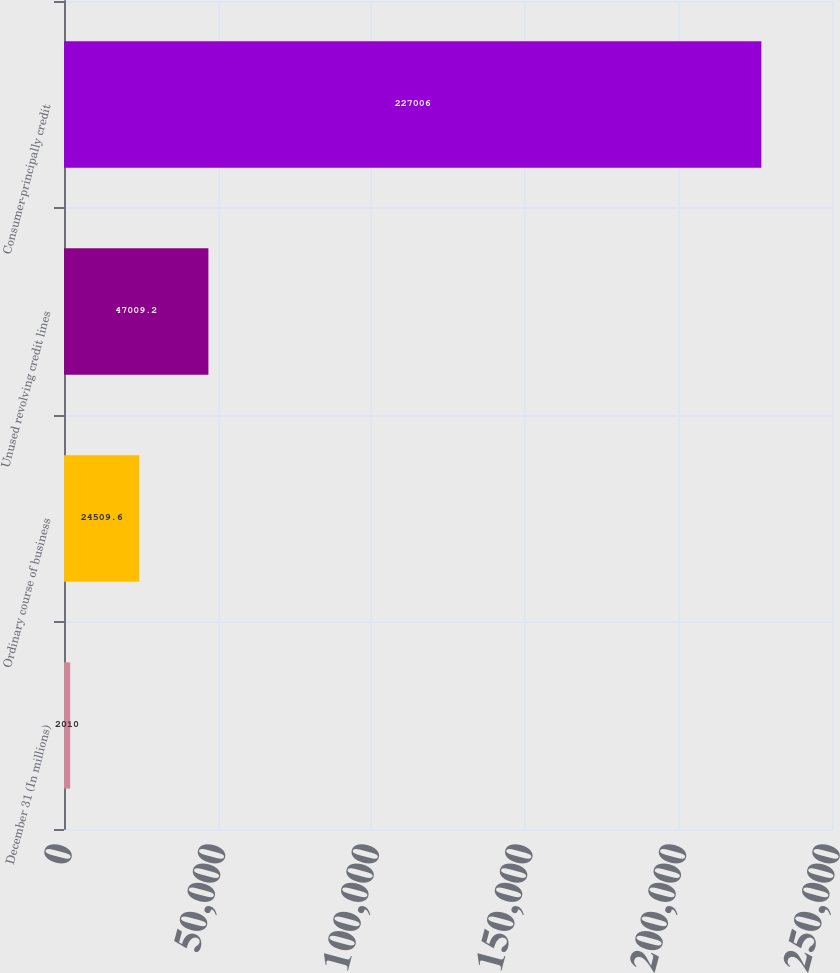Convert chart to OTSL. <chart><loc_0><loc_0><loc_500><loc_500><bar_chart><fcel>December 31 (In millions)<fcel>Ordinary course of business<fcel>Unused revolving credit lines<fcel>Consumer-principally credit<nl><fcel>2010<fcel>24509.6<fcel>47009.2<fcel>227006<nl></chart> 